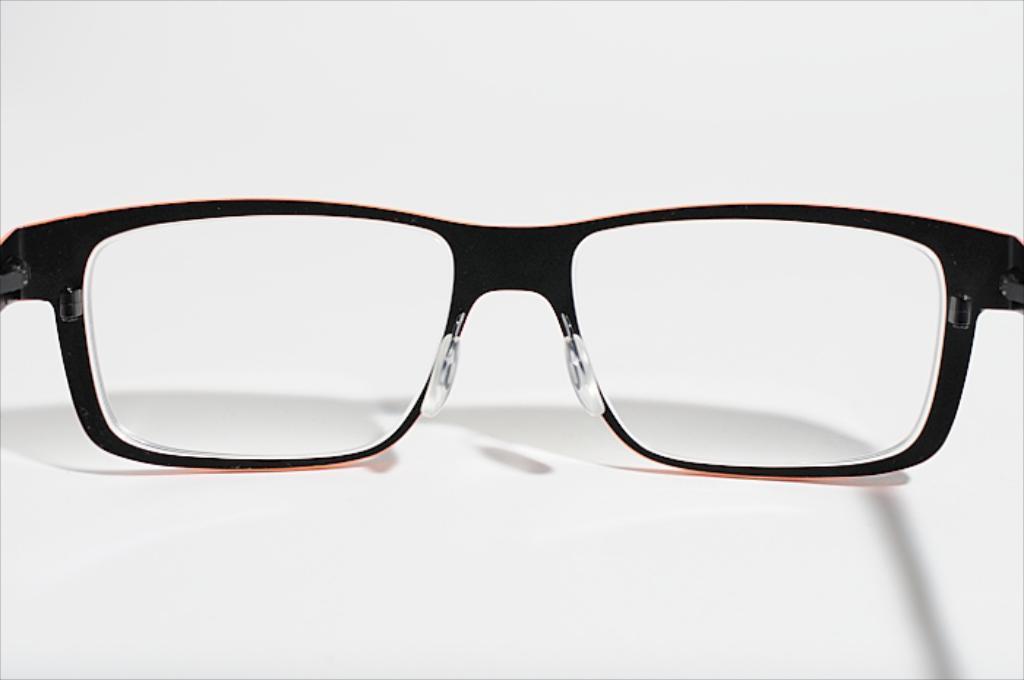Can you describe this image briefly? In this image we can see the spectacles with a white background. 